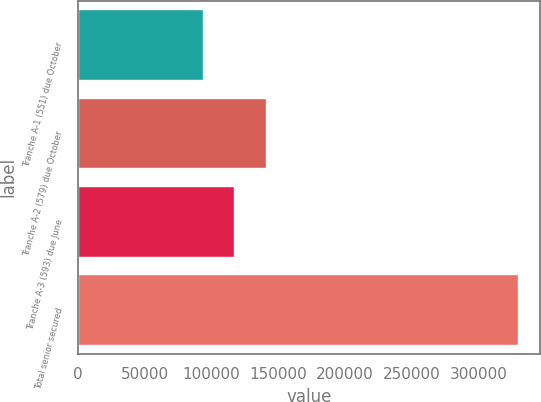<chart> <loc_0><loc_0><loc_500><loc_500><bar_chart><fcel>Tranche A-1 (551) due October<fcel>Tranche A-2 (579) due October<fcel>Tranche A-3 (593) due June<fcel>Total senior secured<nl><fcel>93500<fcel>140700<fcel>117100<fcel>329500<nl></chart> 